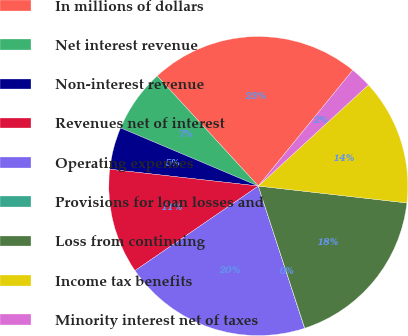Convert chart. <chart><loc_0><loc_0><loc_500><loc_500><pie_chart><fcel>In millions of dollars<fcel>Net interest revenue<fcel>Non-interest revenue<fcel>Revenues net of interest<fcel>Operating expenses<fcel>Provisions for loan losses and<fcel>Loss from continuing<fcel>Income tax benefits<fcel>Minority interest net of taxes<nl><fcel>22.71%<fcel>6.82%<fcel>4.56%<fcel>11.36%<fcel>20.44%<fcel>0.02%<fcel>18.17%<fcel>13.63%<fcel>2.29%<nl></chart> 